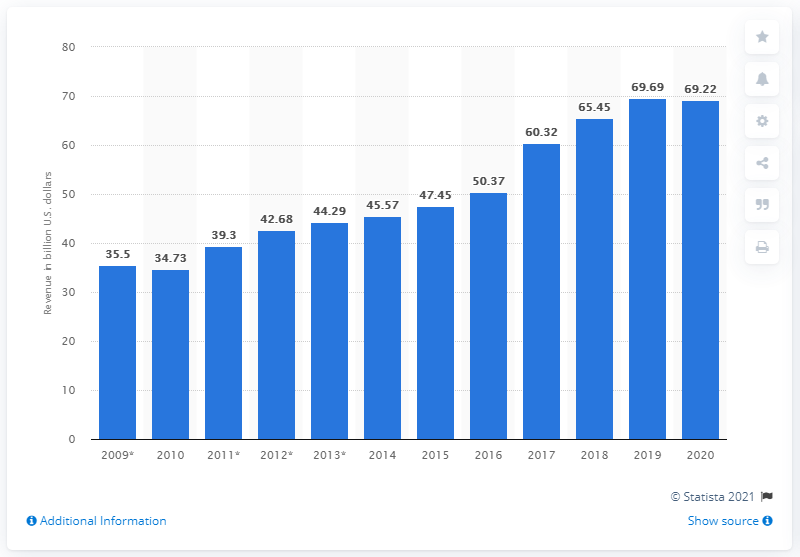List a handful of essential elements in this visual. In the fiscal year of 2020, the FedEx Corporation generated approximately $69.22 billion in revenue. 